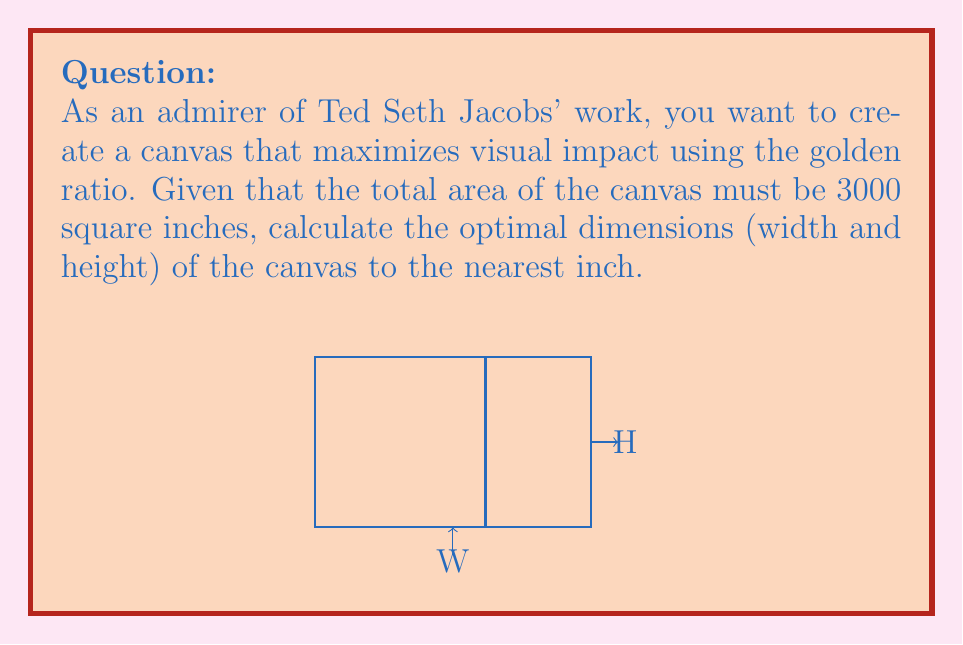Help me with this question. Let's approach this step-by-step:

1) The golden ratio is approximately 1.618. Let's denote the width as W and the height as H.

2) According to the golden ratio, $\frac{W}{H} = 1.618$

3) We know that the area of the canvas is 3000 square inches:
   $W \times H = 3000$

4) Substituting H from the golden ratio equation:
   $W \times (\frac{W}{1.618}) = 3000$

5) Simplifying:
   $\frac{W^2}{1.618} = 3000$

6) Solving for W:
   $W^2 = 3000 \times 1.618 = 4854$
   $W = \sqrt{4854} \approx 69.67$ inches

7) Now we can find H:
   $H = \frac{W}{1.618} \approx 43.06$ inches

8) Rounding to the nearest inch:
   W = 70 inches
   H = 43 inches

9) Let's verify:
   $70 \times 43 = 3010$ square inches (very close to 3000)
   $\frac{70}{43} \approx 1.628$ (very close to 1.618)
Answer: Width: 70 inches, Height: 43 inches 